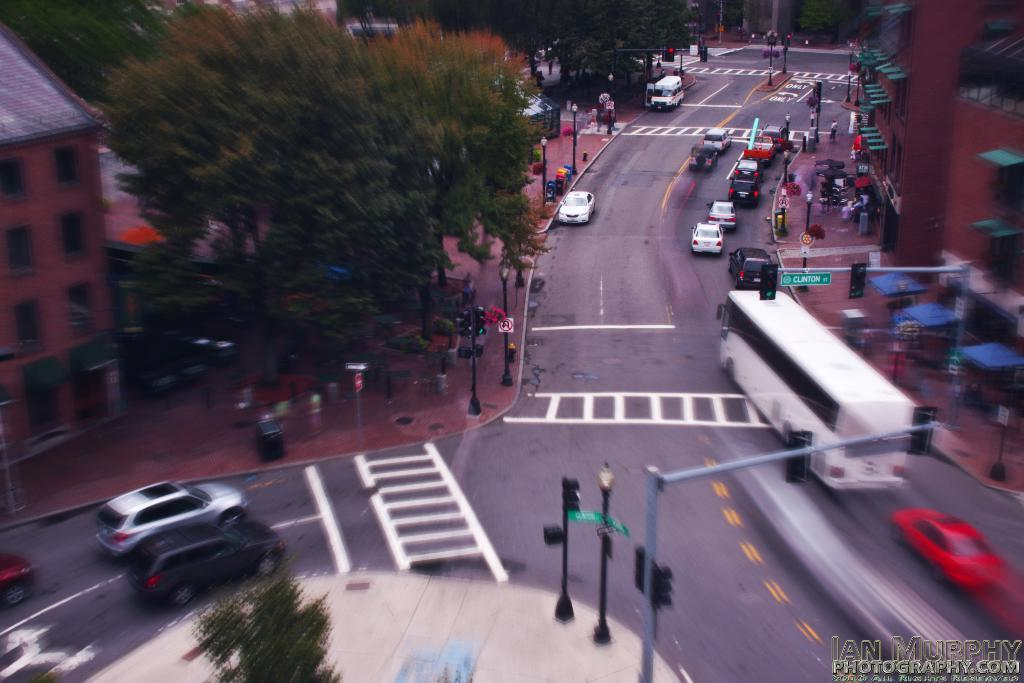What can be seen on the road in the image? There are vehicles on the road in the image. How is the road positioned in relation to the buildings? The road is between buildings in the image. What type of vegetation is visible at the top of the image? There are trees at the top of the image. What structures can be seen at the bottom of the image? There are signal poles at the bottom of the image. Can you see any deer grazing in the trees at the top of the image? There are no deer present in the image; only trees can be seen at the top. What type of lumber is being used to construct the signal poles at the bottom of the image? There is no lumber visible in the image, as the signal poles are not being constructed. 